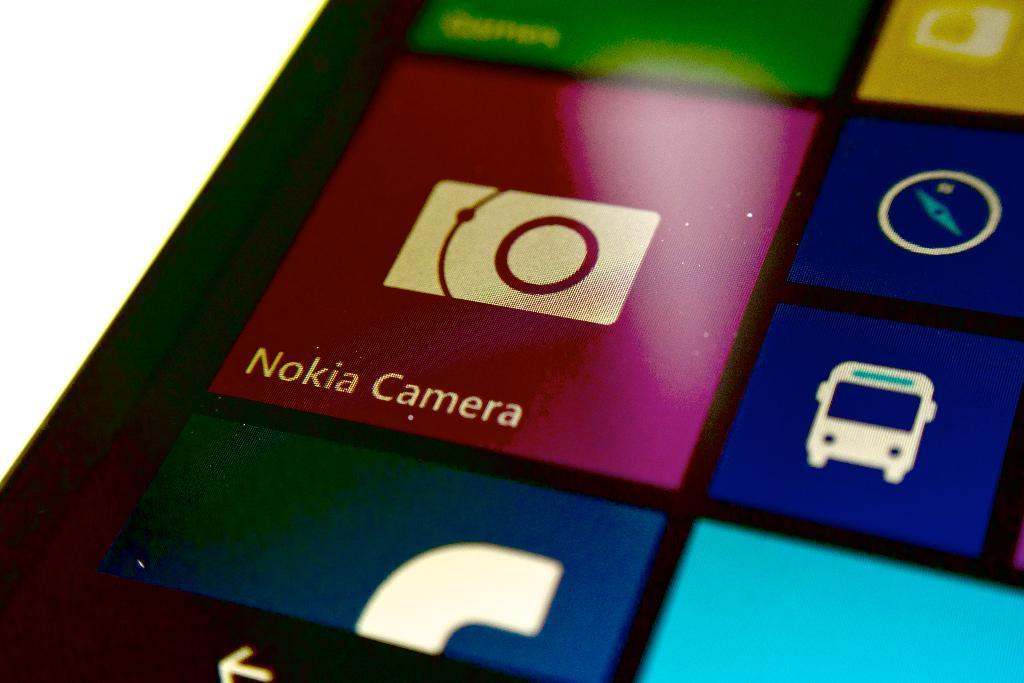<image>
Offer a succinct explanation of the picture presented. Application logos on a phone screen include one for a Nokia Camera. 